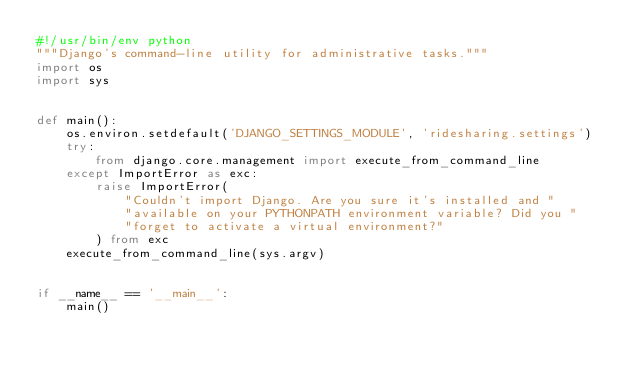<code> <loc_0><loc_0><loc_500><loc_500><_Python_>#!/usr/bin/env python
"""Django's command-line utility for administrative tasks."""
import os
import sys


def main():
    os.environ.setdefault('DJANGO_SETTINGS_MODULE', 'ridesharing.settings')
    try:
        from django.core.management import execute_from_command_line
    except ImportError as exc:
        raise ImportError(
            "Couldn't import Django. Are you sure it's installed and "
            "available on your PYTHONPATH environment variable? Did you "
            "forget to activate a virtual environment?"
        ) from exc
    execute_from_command_line(sys.argv)


if __name__ == '__main__':
    main()
</code> 